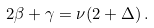Convert formula to latex. <formula><loc_0><loc_0><loc_500><loc_500>2 \beta + \gamma = \nu ( 2 + \Delta ) \, .</formula> 